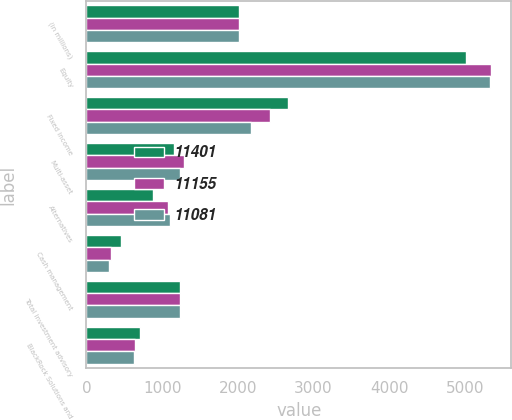Convert chart. <chart><loc_0><loc_0><loc_500><loc_500><stacked_bar_chart><ecel><fcel>(in millions)<fcel>Equity<fcel>Fixed income<fcel>Multi-asset<fcel>Alternatives<fcel>Cash management<fcel>Total investment advisory<fcel>BlackRock Solutions and<nl><fcel>11401<fcel>2016<fcel>5018<fcel>2664<fcel>1157<fcel>878<fcel>458<fcel>1236<fcel>714<nl><fcel>11155<fcel>2015<fcel>5345<fcel>2428<fcel>1287<fcel>1082<fcel>319<fcel>1236<fcel>646<nl><fcel>11081<fcel>2014<fcel>5337<fcel>2171<fcel>1236<fcel>1103<fcel>292<fcel>1236<fcel>635<nl></chart> 